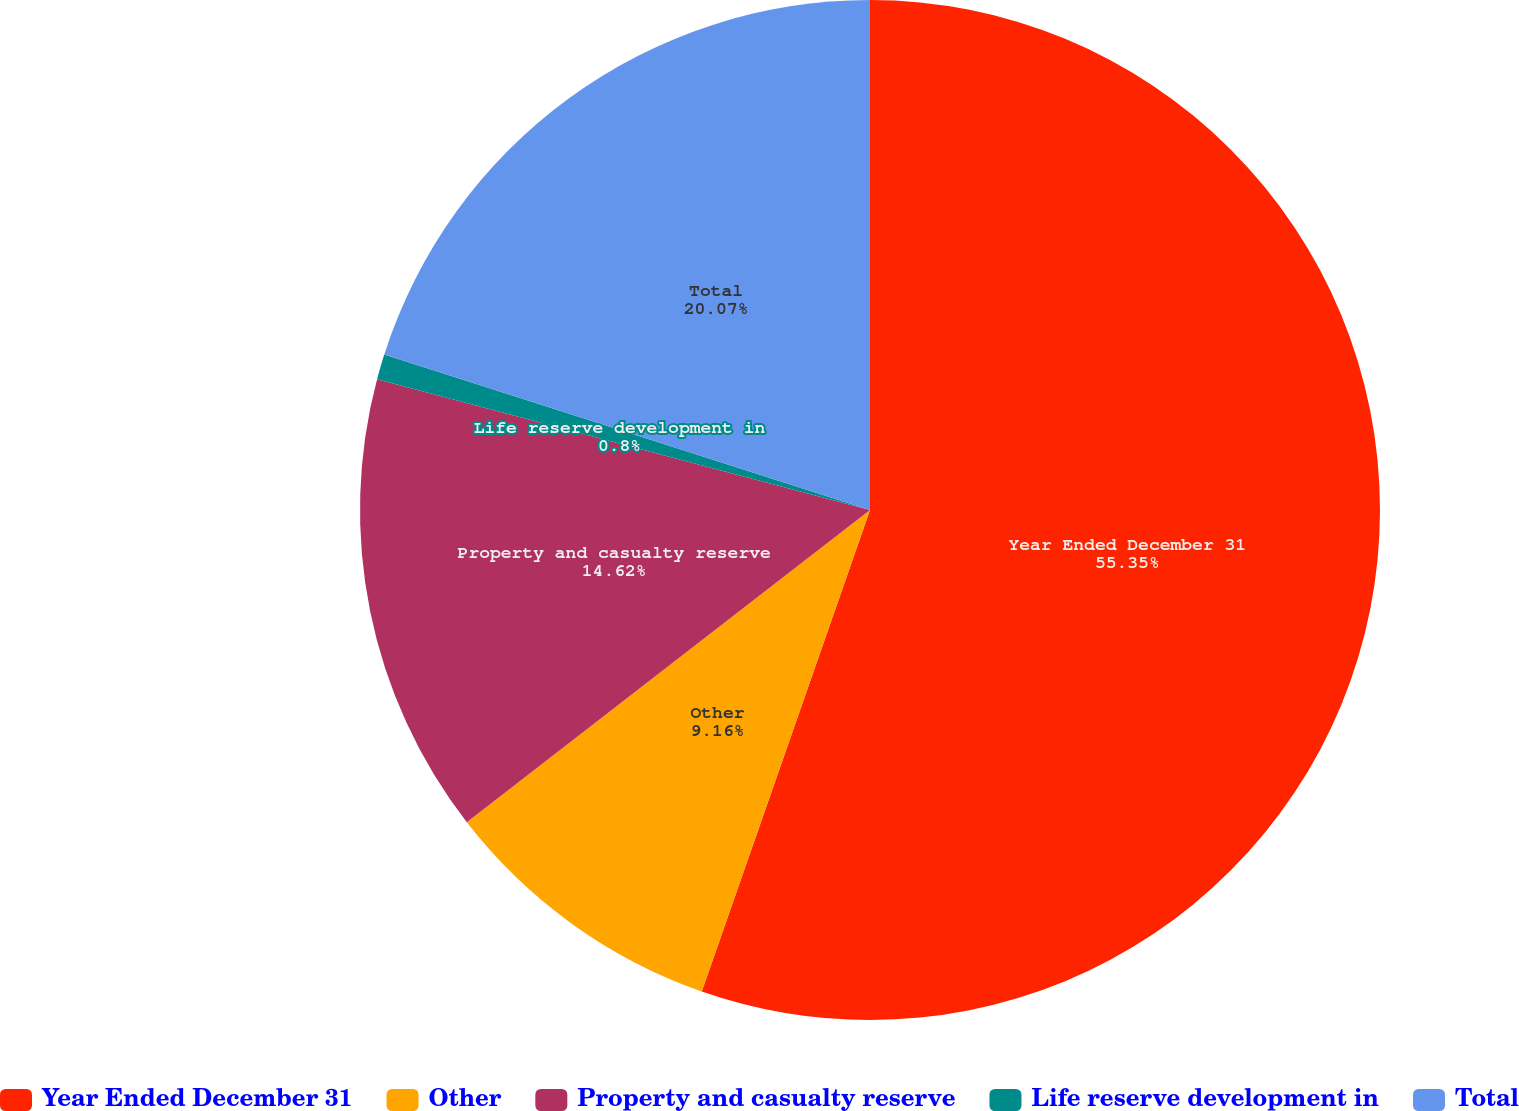<chart> <loc_0><loc_0><loc_500><loc_500><pie_chart><fcel>Year Ended December 31<fcel>Other<fcel>Property and casualty reserve<fcel>Life reserve development in<fcel>Total<nl><fcel>55.35%<fcel>9.16%<fcel>14.62%<fcel>0.8%<fcel>20.07%<nl></chart> 